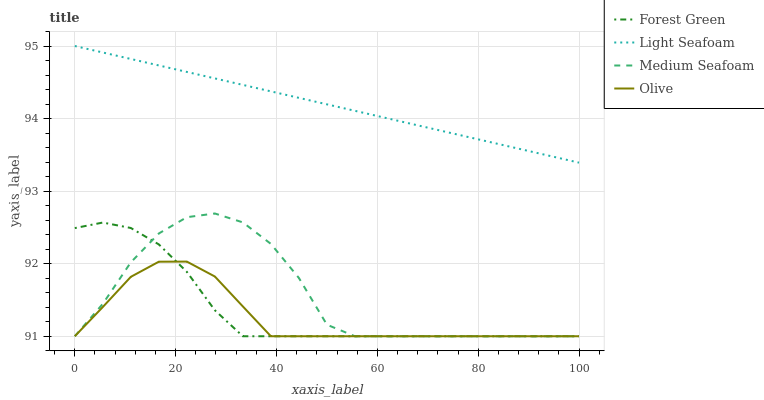Does Olive have the minimum area under the curve?
Answer yes or no. Yes. Does Light Seafoam have the maximum area under the curve?
Answer yes or no. Yes. Does Forest Green have the minimum area under the curve?
Answer yes or no. No. Does Forest Green have the maximum area under the curve?
Answer yes or no. No. Is Light Seafoam the smoothest?
Answer yes or no. Yes. Is Medium Seafoam the roughest?
Answer yes or no. Yes. Is Forest Green the smoothest?
Answer yes or no. No. Is Forest Green the roughest?
Answer yes or no. No. Does Olive have the lowest value?
Answer yes or no. Yes. Does Light Seafoam have the lowest value?
Answer yes or no. No. Does Light Seafoam have the highest value?
Answer yes or no. Yes. Does Forest Green have the highest value?
Answer yes or no. No. Is Olive less than Light Seafoam?
Answer yes or no. Yes. Is Light Seafoam greater than Medium Seafoam?
Answer yes or no. Yes. Does Forest Green intersect Medium Seafoam?
Answer yes or no. Yes. Is Forest Green less than Medium Seafoam?
Answer yes or no. No. Is Forest Green greater than Medium Seafoam?
Answer yes or no. No. Does Olive intersect Light Seafoam?
Answer yes or no. No. 